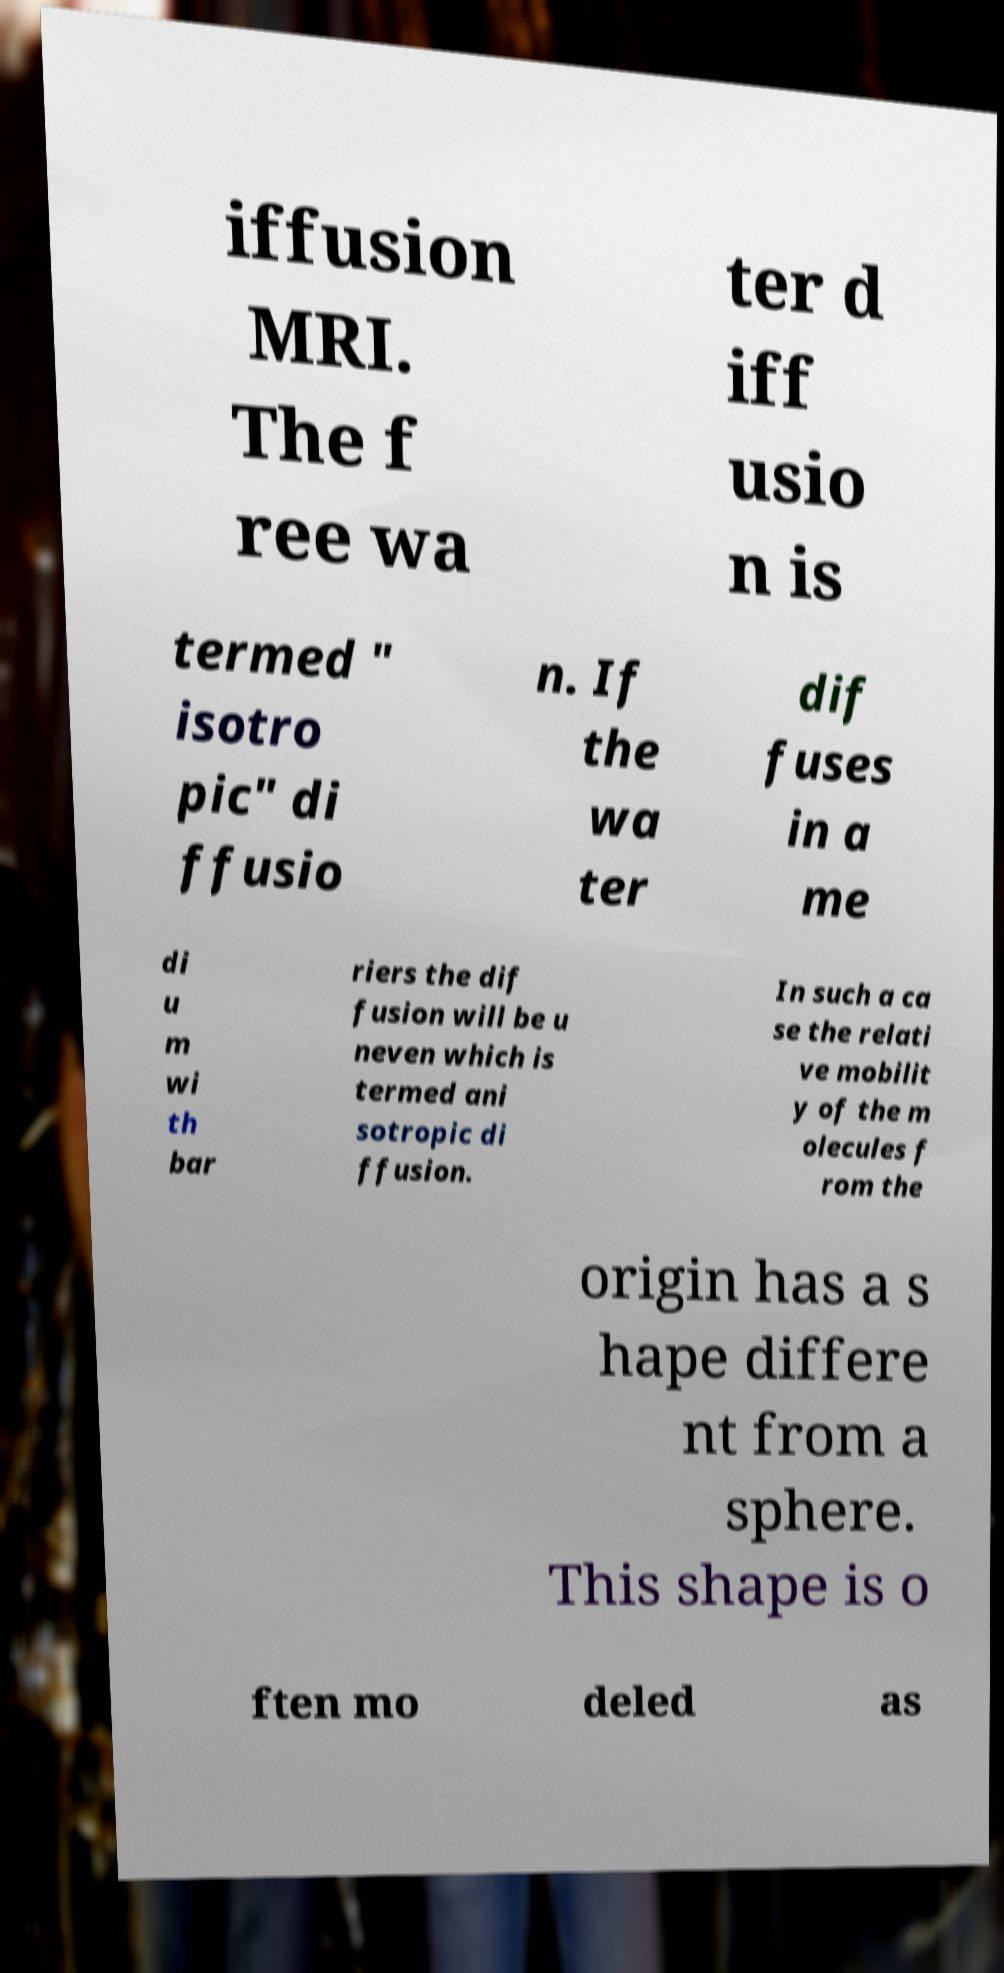Please read and relay the text visible in this image. What does it say? iffusion MRI. The f ree wa ter d iff usio n is termed " isotro pic" di ffusio n. If the wa ter dif fuses in a me di u m wi th bar riers the dif fusion will be u neven which is termed ani sotropic di ffusion. In such a ca se the relati ve mobilit y of the m olecules f rom the origin has a s hape differe nt from a sphere. This shape is o ften mo deled as 